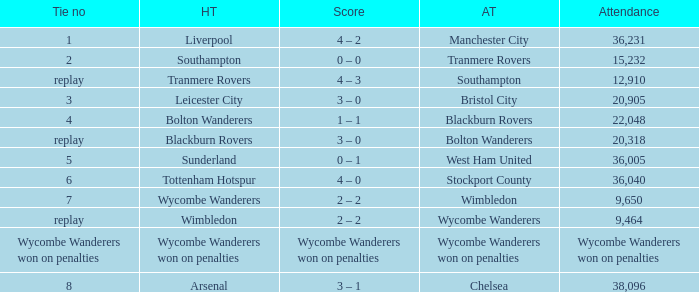What was the name of the away team that had a tie of 2? Tranmere Rovers. 